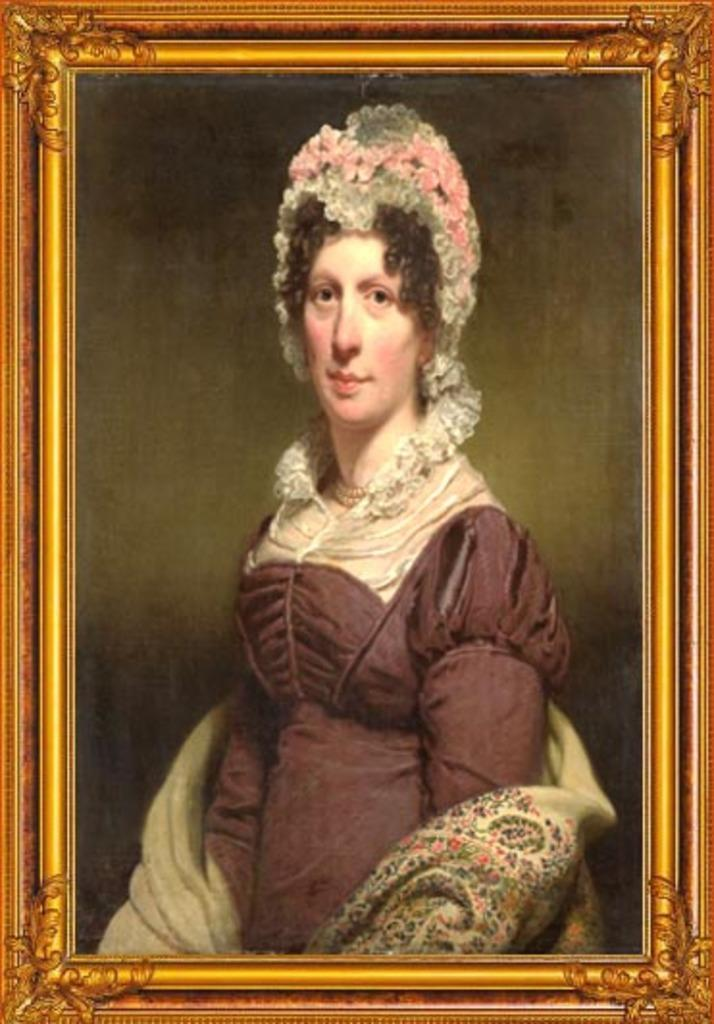What object is present in the image that typically holds a picture? There is a photo frame in the image. What can be seen inside the photo frame? The photo frame contains a picture of a girl. Is the girl wearing a crown in the picture inside the photo frame? There is no information about a crown in the image, as the provided facts only mention the presence of a photo frame and a picture of a girl. 